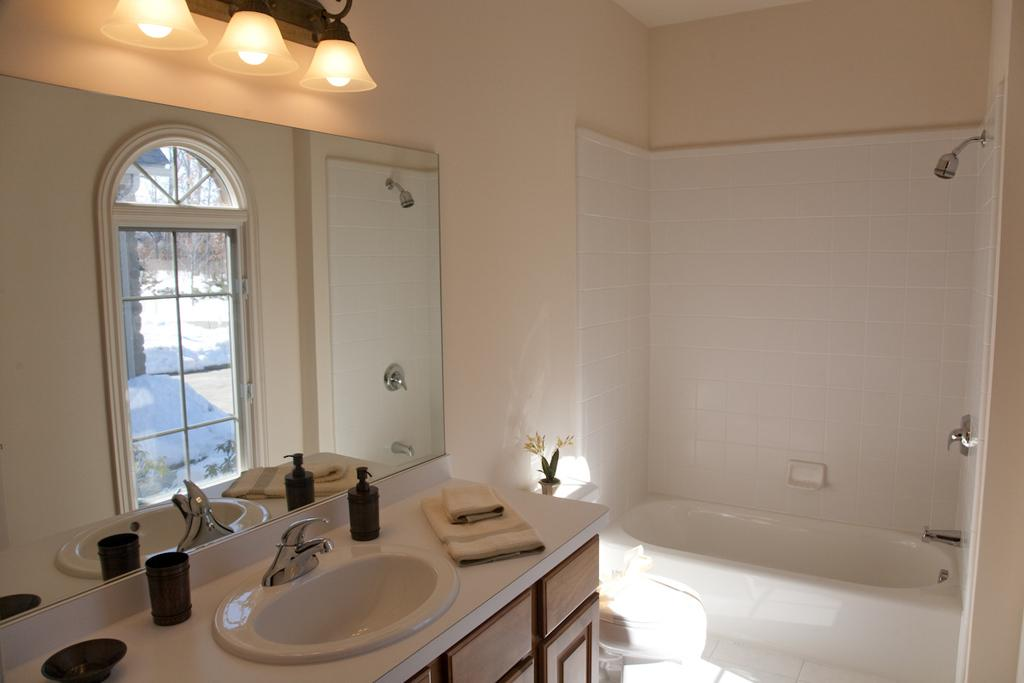What type of room is depicted in the image? The image depicts a washroom. What is one of the main features of a washroom that can be seen in the image? There is a bathtub in the washroom. What is used for personal grooming in the image? There is a mirror in the action or position in the washroom. What is another feature of a washroom that can be seen in the image? There is a shower in the washroom. What provides illumination in the washroom? There are lights in the washroom. What item can be seen on a surface in the washroom? There is a bottle in the washroom. What can be used for drying oneself in the washroom? There are towels in the washroom. What is used for dispensing water in the washroom? There is a tap in the washroom. What type of coat is hanging on the shower rod in the image? There is no coat present in the image; it is a washroom with a bathtub, mirror, shower, lights, bottle, towels, and tap. 